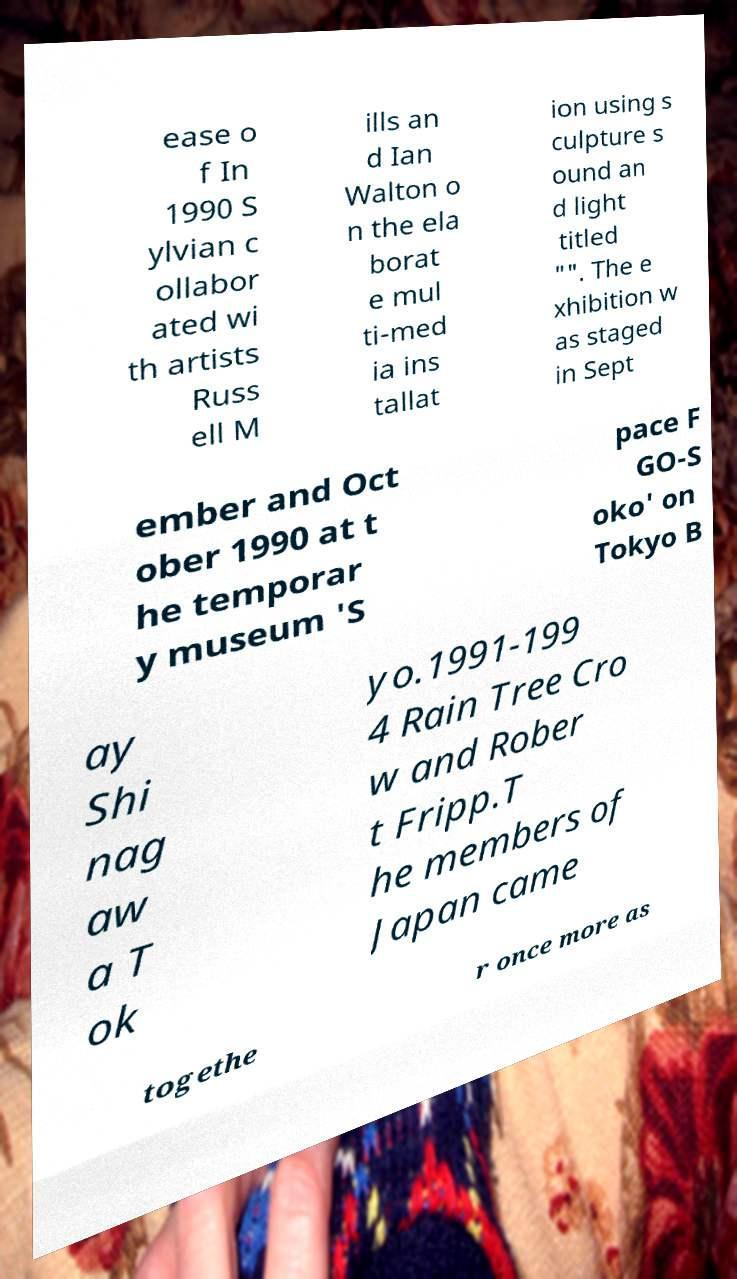I need the written content from this picture converted into text. Can you do that? ease o f In 1990 S ylvian c ollabor ated wi th artists Russ ell M ills an d Ian Walton o n the ela borat e mul ti-med ia ins tallat ion using s culpture s ound an d light titled "". The e xhibition w as staged in Sept ember and Oct ober 1990 at t he temporar y museum 'S pace F GO-S oko' on Tokyo B ay Shi nag aw a T ok yo.1991-199 4 Rain Tree Cro w and Rober t Fripp.T he members of Japan came togethe r once more as 